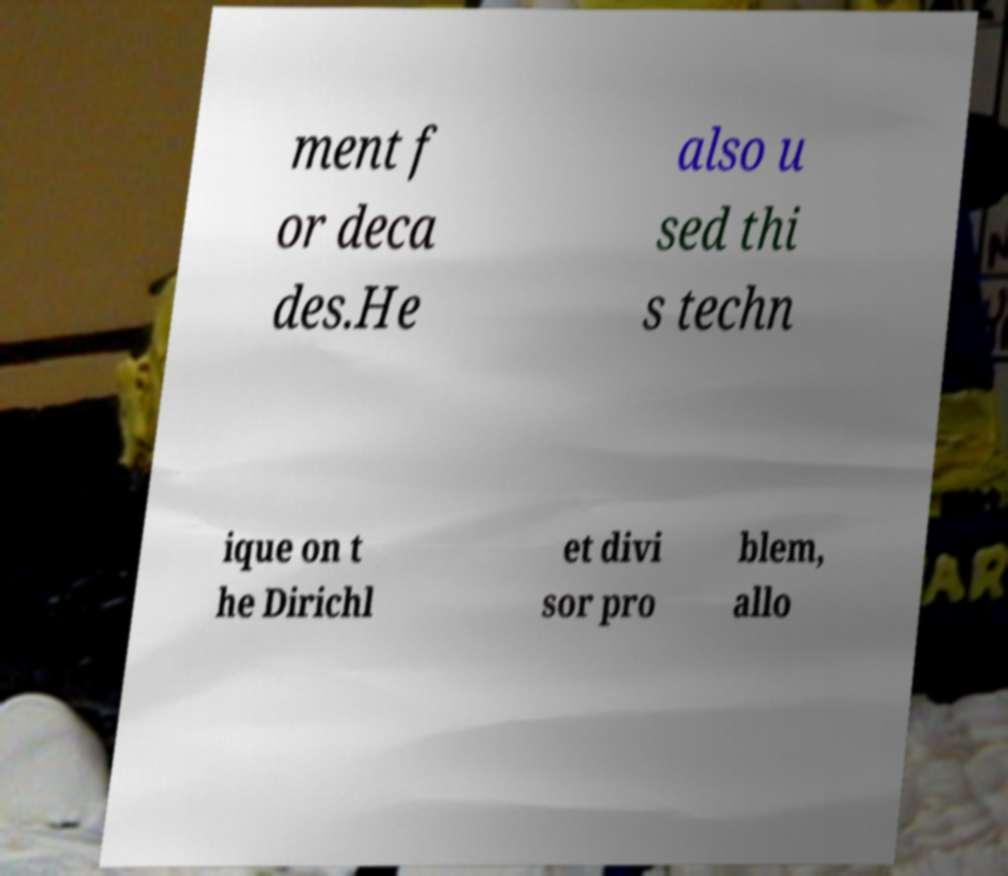Can you accurately transcribe the text from the provided image for me? ment f or deca des.He also u sed thi s techn ique on t he Dirichl et divi sor pro blem, allo 